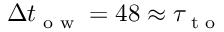<formula> <loc_0><loc_0><loc_500><loc_500>\Delta t _ { o w } = 4 8 \approx \tau _ { t o }</formula> 